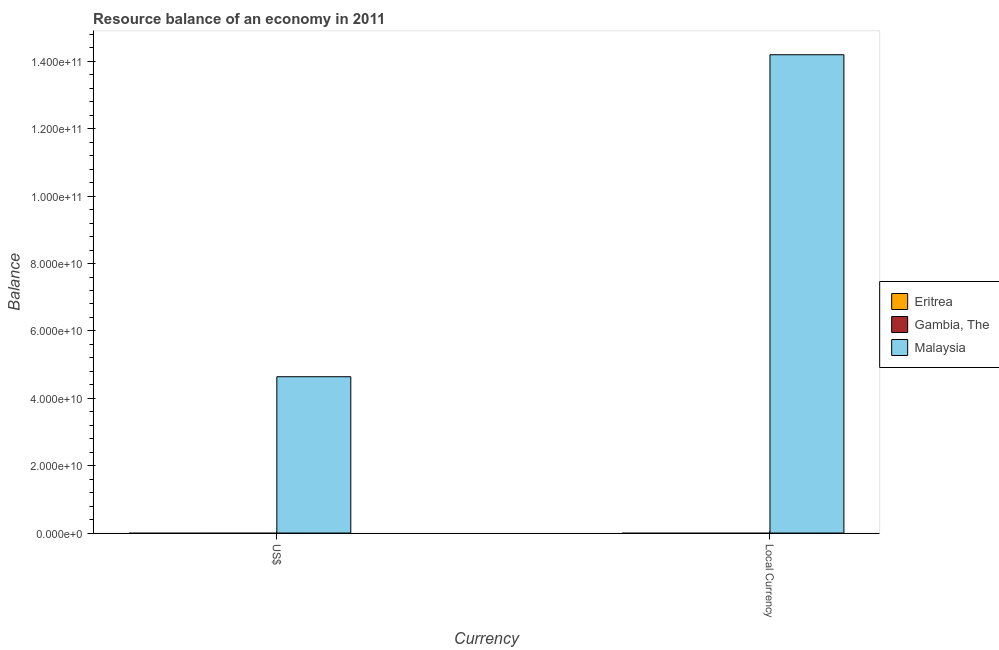Are the number of bars on each tick of the X-axis equal?
Offer a terse response. Yes. What is the label of the 2nd group of bars from the left?
Ensure brevity in your answer.  Local Currency. What is the resource balance in constant us$ in Malaysia?
Your answer should be compact. 1.42e+11. Across all countries, what is the maximum resource balance in constant us$?
Your response must be concise. 1.42e+11. In which country was the resource balance in constant us$ maximum?
Provide a succinct answer. Malaysia. What is the total resource balance in constant us$ in the graph?
Keep it short and to the point. 1.42e+11. What is the difference between the resource balance in constant us$ in Gambia, The and the resource balance in us$ in Malaysia?
Keep it short and to the point. -4.64e+1. What is the average resource balance in constant us$ per country?
Your answer should be compact. 4.73e+1. What is the difference between the resource balance in us$ and resource balance in constant us$ in Malaysia?
Keep it short and to the point. -9.56e+1. In how many countries, is the resource balance in constant us$ greater than 96000000000 units?
Provide a short and direct response. 1. How many countries are there in the graph?
Your answer should be very brief. 3. Does the graph contain grids?
Offer a very short reply. No. How many legend labels are there?
Keep it short and to the point. 3. How are the legend labels stacked?
Keep it short and to the point. Vertical. What is the title of the graph?
Provide a short and direct response. Resource balance of an economy in 2011. What is the label or title of the X-axis?
Your answer should be compact. Currency. What is the label or title of the Y-axis?
Make the answer very short. Balance. What is the Balance in Eritrea in US$?
Give a very brief answer. 0. What is the Balance in Malaysia in US$?
Provide a short and direct response. 4.64e+1. What is the Balance in Gambia, The in Local Currency?
Offer a very short reply. 0. What is the Balance of Malaysia in Local Currency?
Provide a succinct answer. 1.42e+11. Across all Currency, what is the maximum Balance in Malaysia?
Offer a very short reply. 1.42e+11. Across all Currency, what is the minimum Balance of Malaysia?
Ensure brevity in your answer.  4.64e+1. What is the total Balance in Eritrea in the graph?
Provide a succinct answer. 0. What is the total Balance in Gambia, The in the graph?
Offer a terse response. 0. What is the total Balance of Malaysia in the graph?
Offer a terse response. 1.88e+11. What is the difference between the Balance in Malaysia in US$ and that in Local Currency?
Your answer should be compact. -9.56e+1. What is the average Balance in Gambia, The per Currency?
Provide a succinct answer. 0. What is the average Balance in Malaysia per Currency?
Give a very brief answer. 9.42e+1. What is the ratio of the Balance of Malaysia in US$ to that in Local Currency?
Offer a terse response. 0.33. What is the difference between the highest and the second highest Balance of Malaysia?
Provide a succinct answer. 9.56e+1. What is the difference between the highest and the lowest Balance in Malaysia?
Your answer should be very brief. 9.56e+1. 